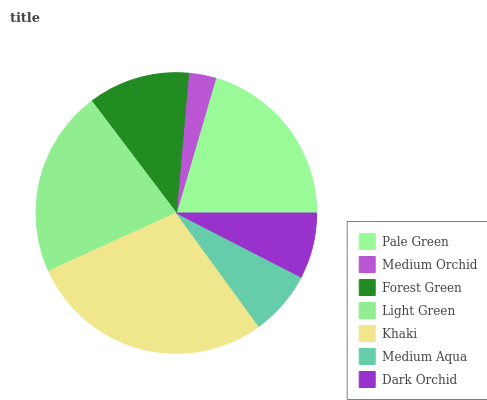Is Medium Orchid the minimum?
Answer yes or no. Yes. Is Khaki the maximum?
Answer yes or no. Yes. Is Forest Green the minimum?
Answer yes or no. No. Is Forest Green the maximum?
Answer yes or no. No. Is Forest Green greater than Medium Orchid?
Answer yes or no. Yes. Is Medium Orchid less than Forest Green?
Answer yes or no. Yes. Is Medium Orchid greater than Forest Green?
Answer yes or no. No. Is Forest Green less than Medium Orchid?
Answer yes or no. No. Is Forest Green the high median?
Answer yes or no. Yes. Is Forest Green the low median?
Answer yes or no. Yes. Is Medium Orchid the high median?
Answer yes or no. No. Is Pale Green the low median?
Answer yes or no. No. 